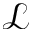<formula> <loc_0><loc_0><loc_500><loc_500>\mathcal { L }</formula> 